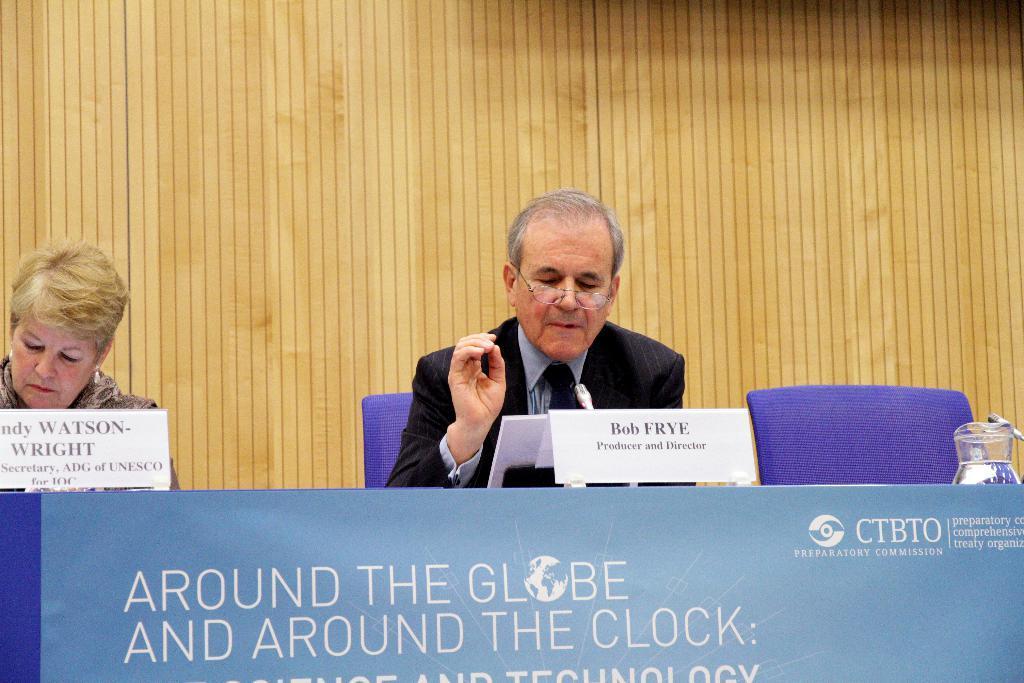Please provide a concise description of this image. In this picture I can see two persons sitting on the cars, there are name plates, mike's, there is a jug of water and there are some objects on the table, there is a board, and in the background there is a wooden wall. 